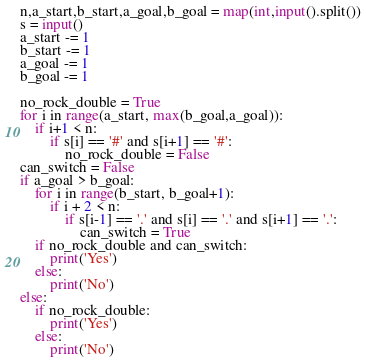<code> <loc_0><loc_0><loc_500><loc_500><_Python_>n,a_start,b_start,a_goal,b_goal = map(int,input().split())
s = input()
a_start -= 1
b_start -= 1
a_goal -= 1
b_goal -= 1

no_rock_double = True
for i in range(a_start, max(b_goal,a_goal)):
    if i+1 < n:
        if s[i] == '#' and s[i+1] == '#':
            no_rock_double = False
can_switch = False
if a_goal > b_goal:
    for i in range(b_start, b_goal+1):
        if i + 2 < n:
            if s[i-1] == '.' and s[i] == '.' and s[i+1] == '.':
                can_switch = True
    if no_rock_double and can_switch:
        print('Yes')
    else:
        print('No')
else:
    if no_rock_double:
        print('Yes')
    else:
        print('No')

</code> 